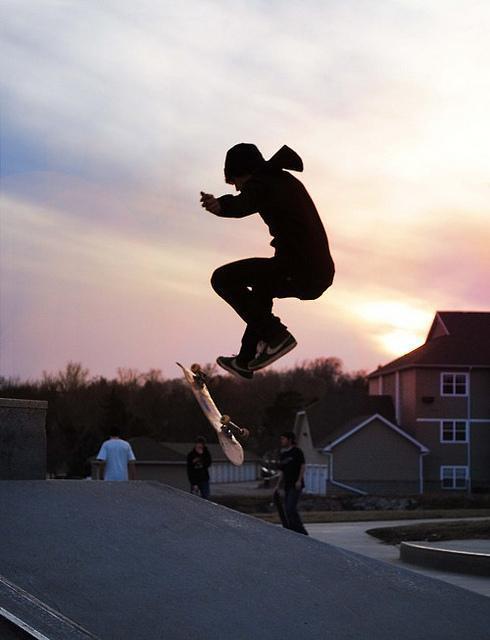How many people in the picture?
Give a very brief answer. 4. How many bananas are there?
Give a very brief answer. 0. 